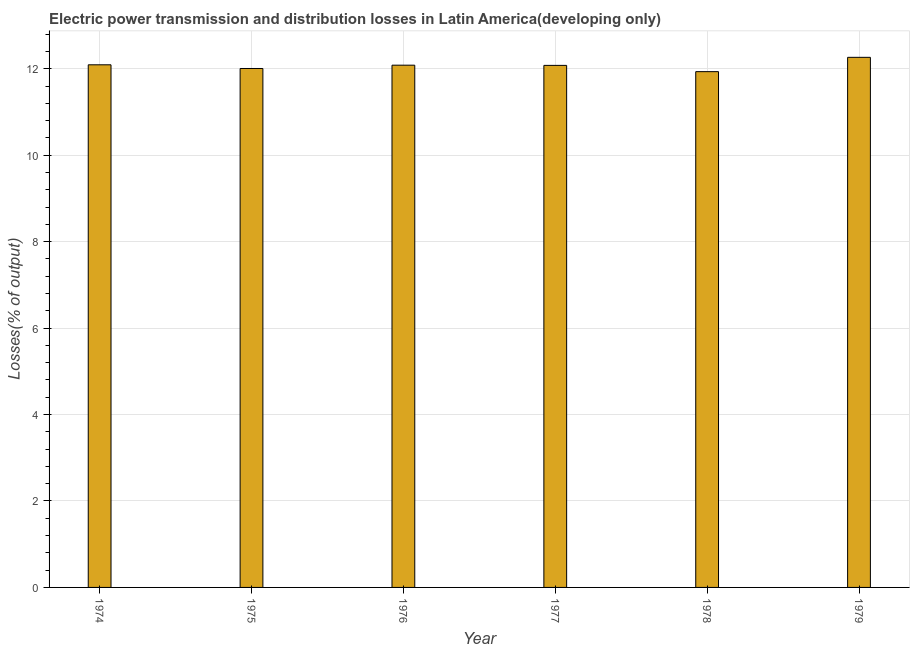Does the graph contain any zero values?
Offer a very short reply. No. Does the graph contain grids?
Offer a terse response. Yes. What is the title of the graph?
Provide a succinct answer. Electric power transmission and distribution losses in Latin America(developing only). What is the label or title of the Y-axis?
Ensure brevity in your answer.  Losses(% of output). What is the electric power transmission and distribution losses in 1974?
Make the answer very short. 12.09. Across all years, what is the maximum electric power transmission and distribution losses?
Keep it short and to the point. 12.26. Across all years, what is the minimum electric power transmission and distribution losses?
Give a very brief answer. 11.93. In which year was the electric power transmission and distribution losses maximum?
Give a very brief answer. 1979. In which year was the electric power transmission and distribution losses minimum?
Make the answer very short. 1978. What is the sum of the electric power transmission and distribution losses?
Provide a succinct answer. 72.45. What is the difference between the electric power transmission and distribution losses in 1975 and 1977?
Keep it short and to the point. -0.07. What is the average electric power transmission and distribution losses per year?
Offer a terse response. 12.07. What is the median electric power transmission and distribution losses?
Offer a terse response. 12.08. What is the ratio of the electric power transmission and distribution losses in 1975 to that in 1978?
Provide a succinct answer. 1.01. Is the difference between the electric power transmission and distribution losses in 1974 and 1976 greater than the difference between any two years?
Make the answer very short. No. What is the difference between the highest and the second highest electric power transmission and distribution losses?
Provide a short and direct response. 0.17. Is the sum of the electric power transmission and distribution losses in 1975 and 1979 greater than the maximum electric power transmission and distribution losses across all years?
Give a very brief answer. Yes. What is the difference between the highest and the lowest electric power transmission and distribution losses?
Give a very brief answer. 0.33. How many bars are there?
Make the answer very short. 6. Are all the bars in the graph horizontal?
Keep it short and to the point. No. What is the difference between two consecutive major ticks on the Y-axis?
Your response must be concise. 2. What is the Losses(% of output) in 1974?
Provide a succinct answer. 12.09. What is the Losses(% of output) in 1975?
Your response must be concise. 12.01. What is the Losses(% of output) of 1976?
Your answer should be compact. 12.08. What is the Losses(% of output) of 1977?
Provide a succinct answer. 12.08. What is the Losses(% of output) in 1978?
Provide a succinct answer. 11.93. What is the Losses(% of output) of 1979?
Provide a succinct answer. 12.26. What is the difference between the Losses(% of output) in 1974 and 1975?
Offer a very short reply. 0.09. What is the difference between the Losses(% of output) in 1974 and 1976?
Your answer should be very brief. 0.01. What is the difference between the Losses(% of output) in 1974 and 1977?
Your answer should be compact. 0.01. What is the difference between the Losses(% of output) in 1974 and 1978?
Offer a very short reply. 0.16. What is the difference between the Losses(% of output) in 1974 and 1979?
Ensure brevity in your answer.  -0.17. What is the difference between the Losses(% of output) in 1975 and 1976?
Give a very brief answer. -0.08. What is the difference between the Losses(% of output) in 1975 and 1977?
Make the answer very short. -0.07. What is the difference between the Losses(% of output) in 1975 and 1978?
Offer a very short reply. 0.07. What is the difference between the Losses(% of output) in 1975 and 1979?
Your answer should be very brief. -0.26. What is the difference between the Losses(% of output) in 1976 and 1977?
Provide a short and direct response. 0. What is the difference between the Losses(% of output) in 1976 and 1978?
Offer a terse response. 0.15. What is the difference between the Losses(% of output) in 1976 and 1979?
Offer a terse response. -0.18. What is the difference between the Losses(% of output) in 1977 and 1978?
Provide a short and direct response. 0.14. What is the difference between the Losses(% of output) in 1977 and 1979?
Ensure brevity in your answer.  -0.19. What is the difference between the Losses(% of output) in 1978 and 1979?
Your answer should be compact. -0.33. What is the ratio of the Losses(% of output) in 1974 to that in 1975?
Offer a terse response. 1.01. What is the ratio of the Losses(% of output) in 1974 to that in 1979?
Your response must be concise. 0.99. What is the ratio of the Losses(% of output) in 1975 to that in 1976?
Give a very brief answer. 0.99. What is the ratio of the Losses(% of output) in 1975 to that in 1977?
Offer a very short reply. 0.99. What is the ratio of the Losses(% of output) in 1975 to that in 1979?
Offer a terse response. 0.98. What is the ratio of the Losses(% of output) in 1976 to that in 1977?
Provide a succinct answer. 1. What is the ratio of the Losses(% of output) in 1976 to that in 1978?
Your answer should be compact. 1.01. What is the ratio of the Losses(% of output) in 1978 to that in 1979?
Keep it short and to the point. 0.97. 